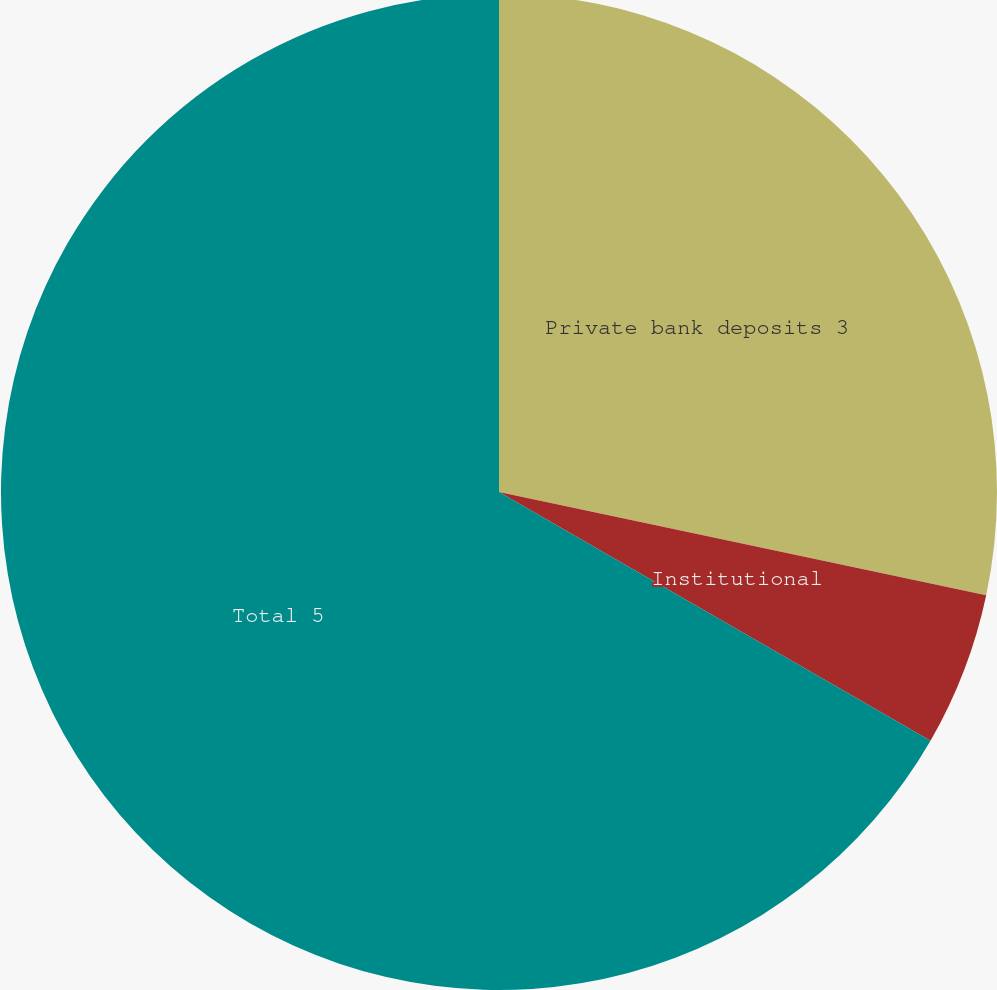<chart> <loc_0><loc_0><loc_500><loc_500><pie_chart><fcel>Private bank deposits 3<fcel>Institutional<fcel>Total 5<nl><fcel>28.32%<fcel>5.0%<fcel>66.68%<nl></chart> 